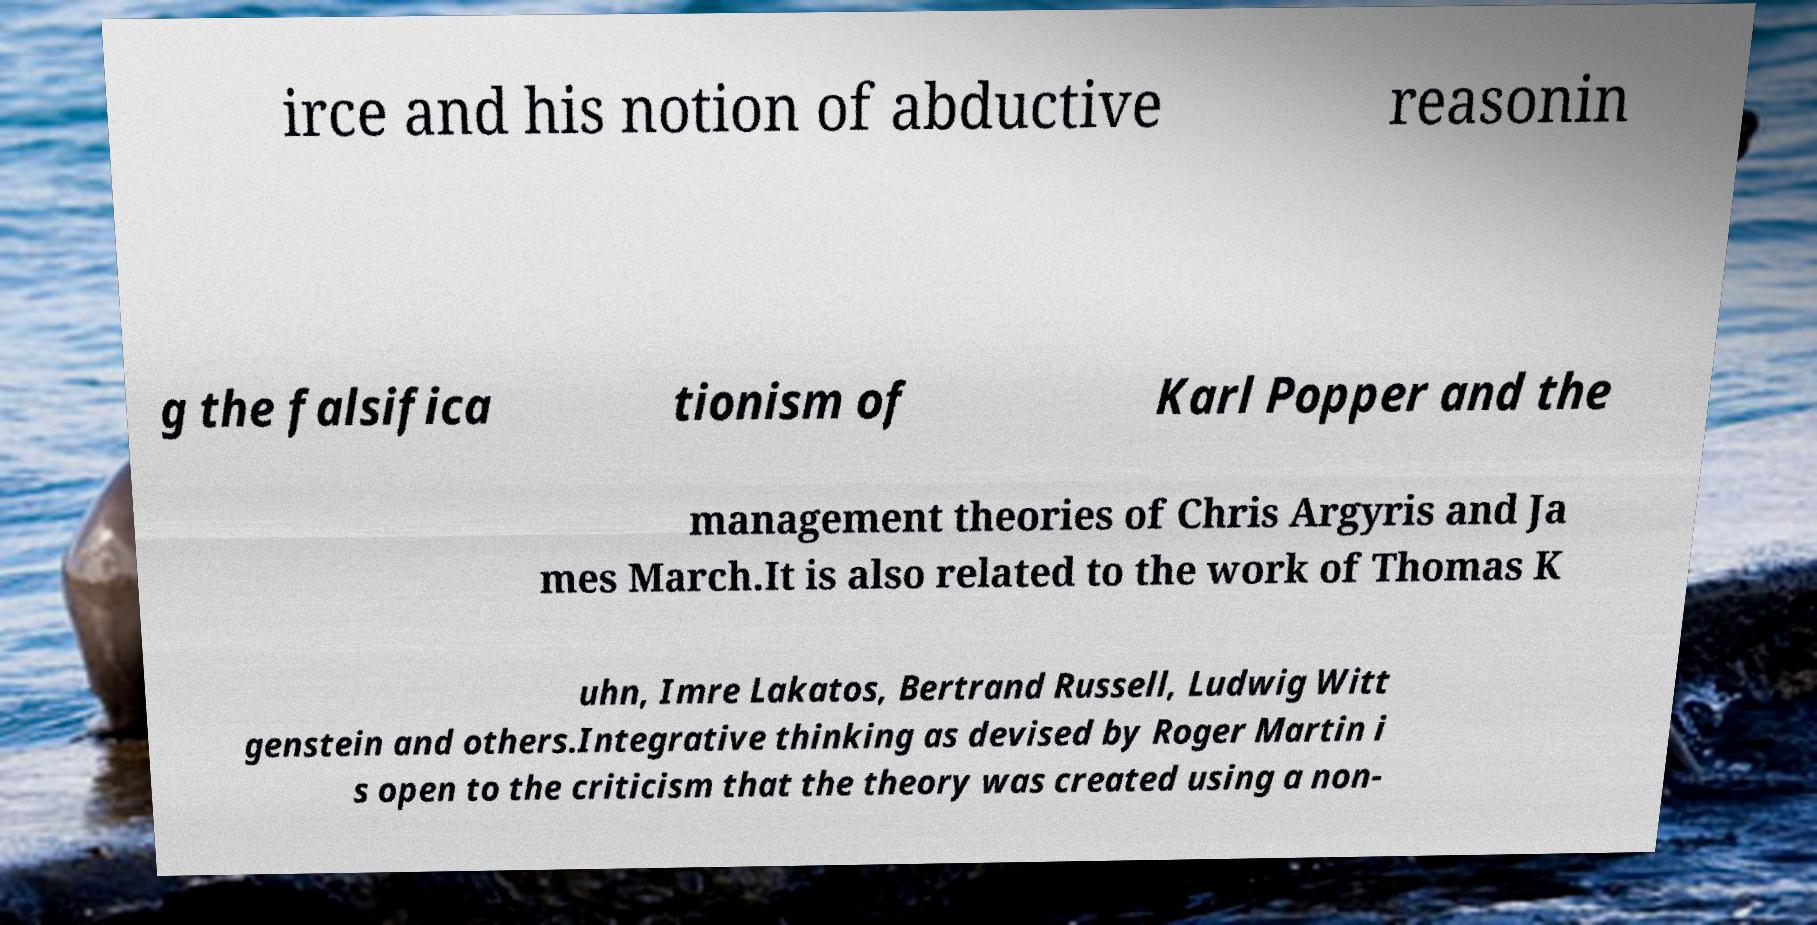Could you extract and type out the text from this image? irce and his notion of abductive reasonin g the falsifica tionism of Karl Popper and the management theories of Chris Argyris and Ja mes March.It is also related to the work of Thomas K uhn, Imre Lakatos, Bertrand Russell, Ludwig Witt genstein and others.Integrative thinking as devised by Roger Martin i s open to the criticism that the theory was created using a non- 